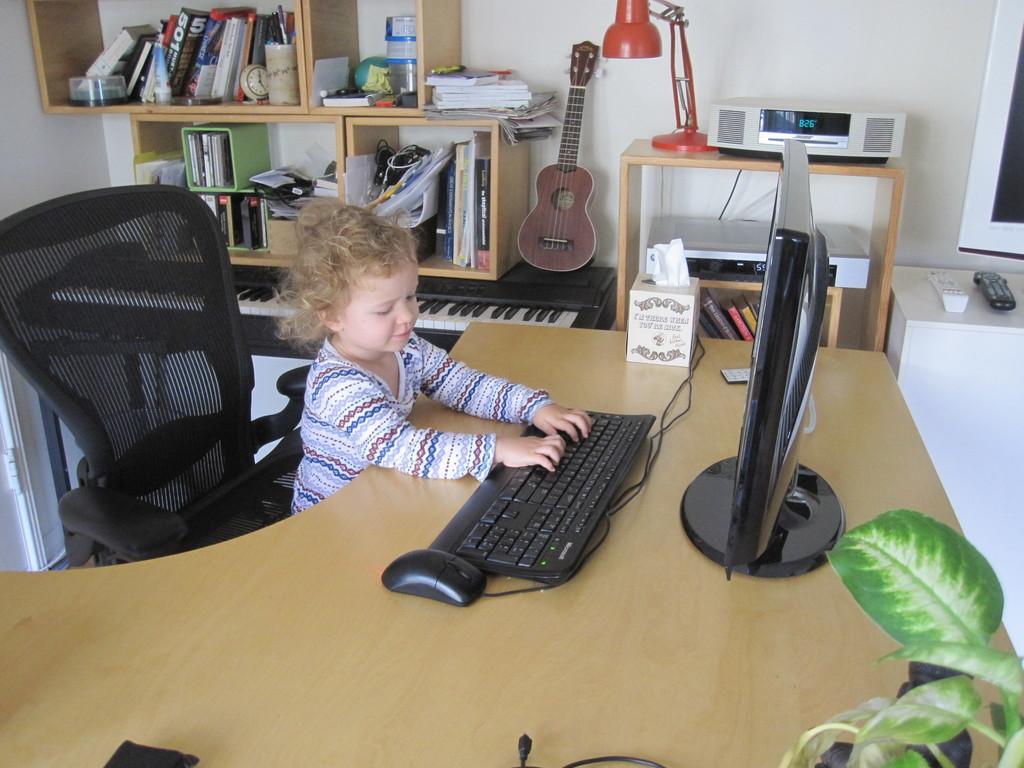Describe this image in one or two sentences. This image is clicked inside a room where there is a table in the middle, on the table there is a computer. In the bottom right corner there is a plant. There is a chair on which a child is sitting. There is a tissue box. There is a guitar, keyboard and bookshelves. books are there in bookshelves. There are remotes on the right side. 